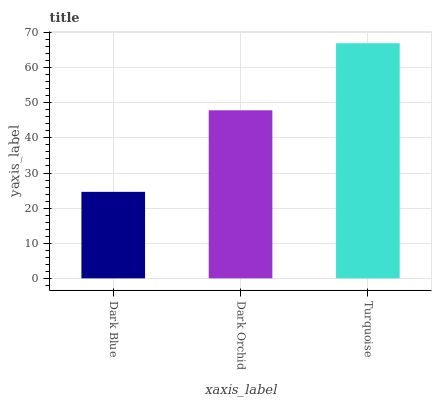Is Dark Orchid the minimum?
Answer yes or no. No. Is Dark Orchid the maximum?
Answer yes or no. No. Is Dark Orchid greater than Dark Blue?
Answer yes or no. Yes. Is Dark Blue less than Dark Orchid?
Answer yes or no. Yes. Is Dark Blue greater than Dark Orchid?
Answer yes or no. No. Is Dark Orchid less than Dark Blue?
Answer yes or no. No. Is Dark Orchid the high median?
Answer yes or no. Yes. Is Dark Orchid the low median?
Answer yes or no. Yes. Is Dark Blue the high median?
Answer yes or no. No. Is Dark Blue the low median?
Answer yes or no. No. 